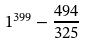Convert formula to latex. <formula><loc_0><loc_0><loc_500><loc_500>1 ^ { 3 9 9 } - \frac { 4 9 4 } { 3 2 5 }</formula> 